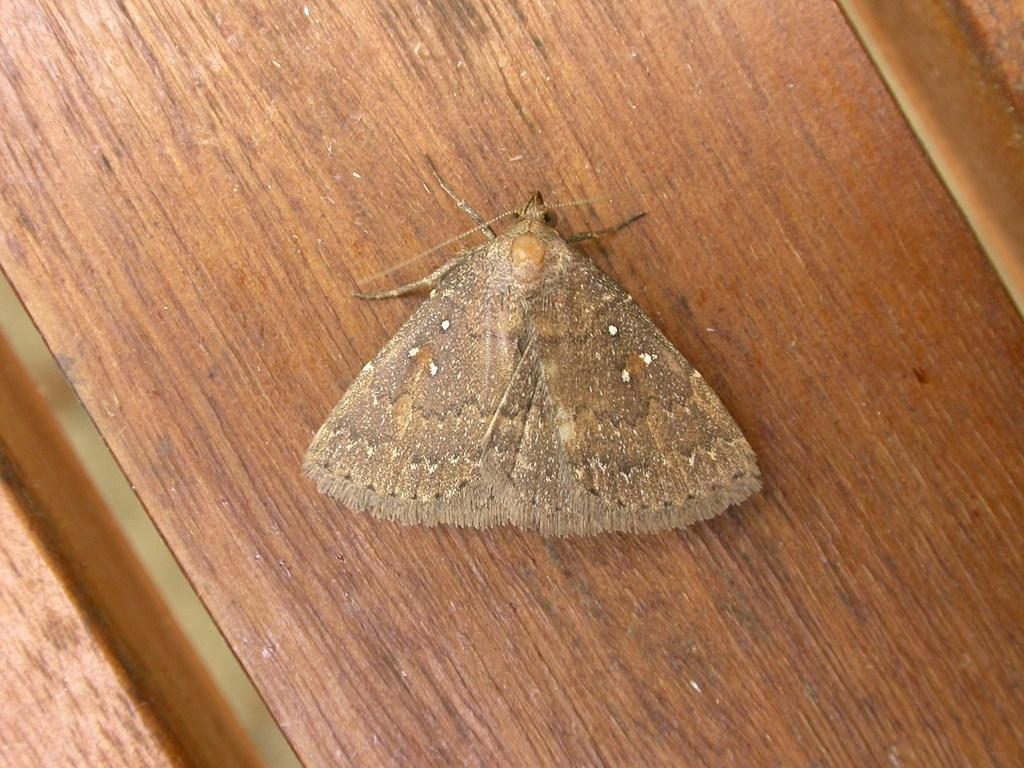What type of insect is in the image? There is a house moth in the image. What surface is the house moth on? The house moth is on a wooden platform. What type of minister is walking on the sidewalk in the image? There is no minister or sidewalk present in the image; it only features a house moth on a wooden platform. What type of rake is being used to clean the area around the house moth in the image? There is no rake present in the image; it only features a house moth on a wooden platform. 